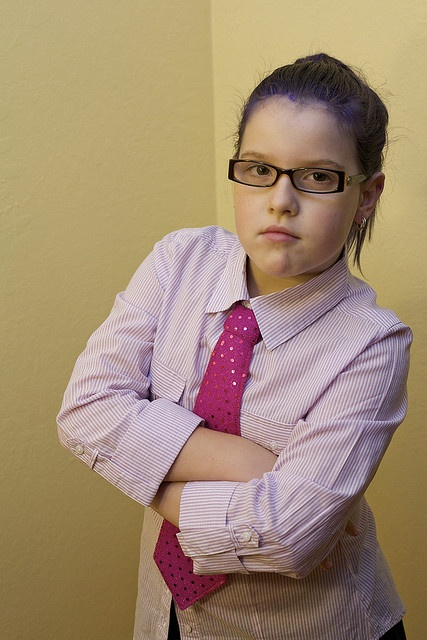Describe the objects in this image and their specific colors. I can see people in tan, darkgray, lightgray, and gray tones and tie in tan, purple, maroon, and brown tones in this image. 